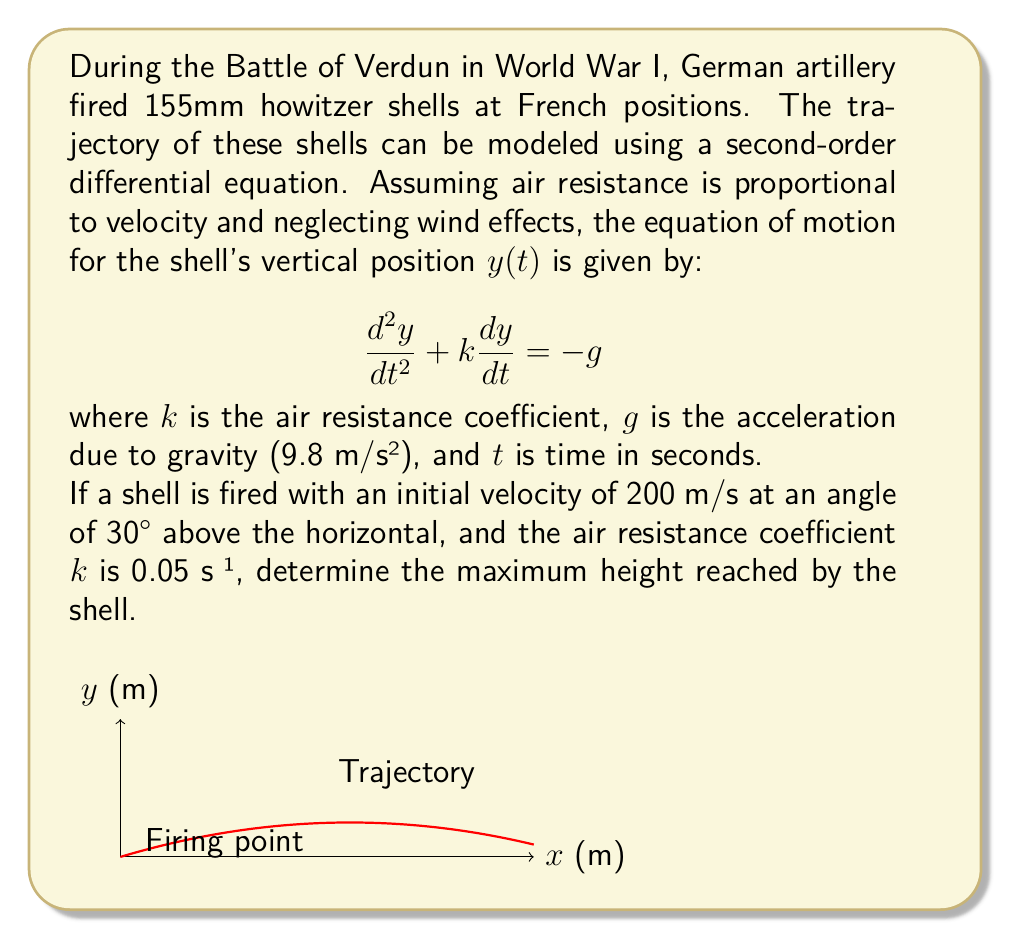Provide a solution to this math problem. To solve this problem, we'll follow these steps:

1) First, we need to decompose the initial velocity into vertical and horizontal components:
   $v_{0y} = 200 \sin(30°) = 100$ m/s
   $v_{0x} = 200 \cos(30°) = 173.2$ m/s

2) The vertical motion is described by the given differential equation. To find the maximum height, we need to find when the vertical velocity becomes zero.

3) Let $v = \frac{dy}{dt}$. Then our equation becomes:

   $$\frac{dv}{dt} + kv = -g$$

4) This is a first-order linear differential equation. The general solution is:

   $$v(t) = Ce^{-kt} - \frac{g}{k}$$

5) Using the initial condition $v(0) = 100$ m/s, we can find C:

   $$100 = C - \frac{g}{k}$$
   $$C = 100 + \frac{g}{k} = 100 + \frac{9.8}{0.05} = 296$$

6) So our velocity function is:

   $$v(t) = 296e^{-0.05t} - 196$$

7) The maximum height occurs when $v(t) = 0$:

   $$296e^{-0.05t} - 196 = 0$$
   $$e^{-0.05t} = \frac{196}{296} = \frac{2}{3}$$
   $$-0.05t = \ln(\frac{2}{3})$$
   $$t = -\frac{1}{0.05}\ln(\frac{2}{3}) = 8.11\text{ s}$$

8) To find the maximum height, we integrate the velocity function:

   $$y(t) = \int v(t) dt = -5920e^{-0.05t} - 196t + C$$

9) Using the initial condition $y(0) = 0$, we find $C = 5920$.

10) The maximum height is then:

    $$y_{max} = y(8.11) = -5920e^{-0.05(8.11)} - 196(8.11) + 5920 = 509.7\text{ m}$$

Therefore, the maximum height reached by the shell is approximately 509.7 meters.
Answer: 509.7 m 